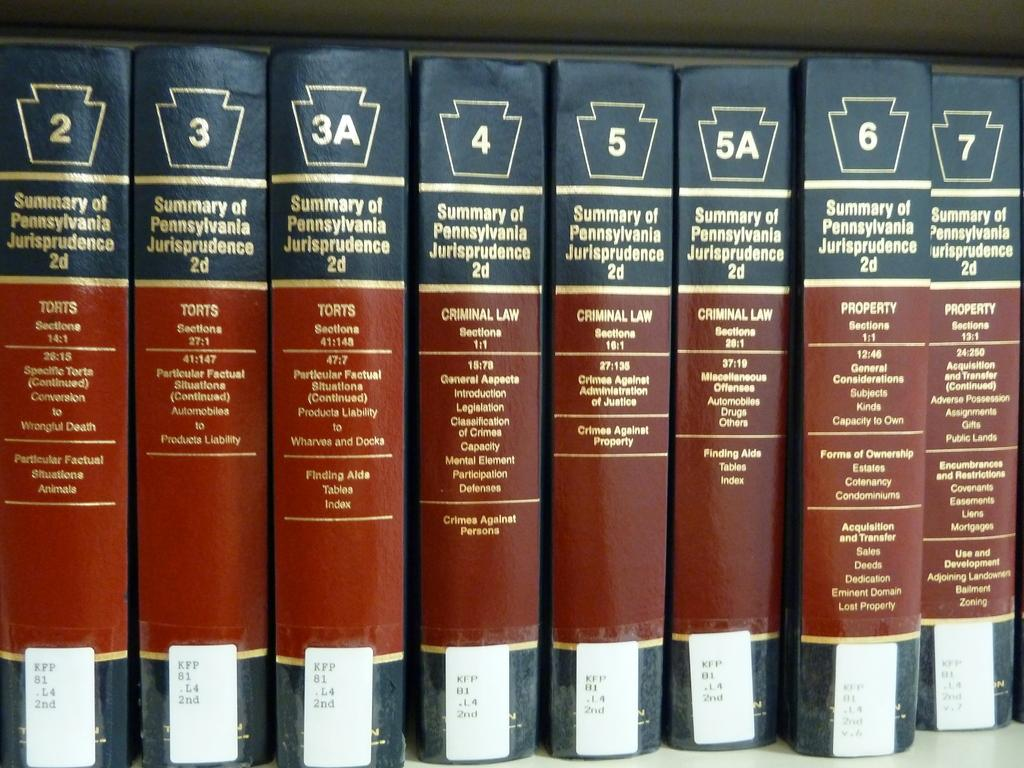How many books are visible in the image? There are eight books in the image. How are the books arranged in the image? The books are arranged one beside the other. What can be seen on the books in the image? There is text and numbers written on the books. What religion is being practiced in the image? There is no indication of any religious practice in the image; it only shows eight books arranged one beside the other. 